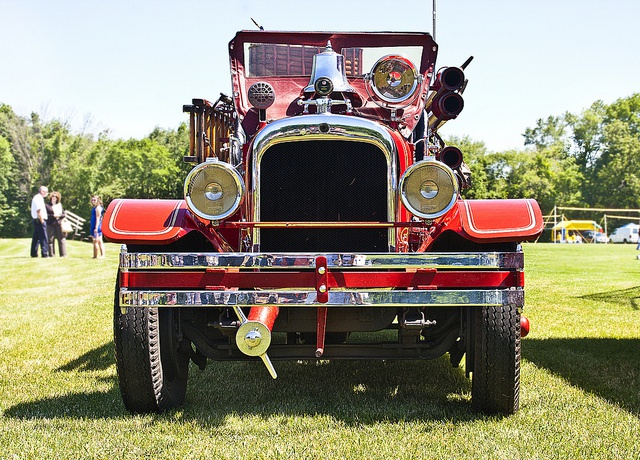Describe the objects in this image and their specific colors. I can see truck in lavender, black, maroon, white, and gray tones, people in lavender, white, gray, black, and darkgray tones, people in lavender, white, black, and gray tones, people in lavender, white, tan, darkblue, and gray tones, and car in lavender, lightgray, darkgray, gray, and black tones in this image. 